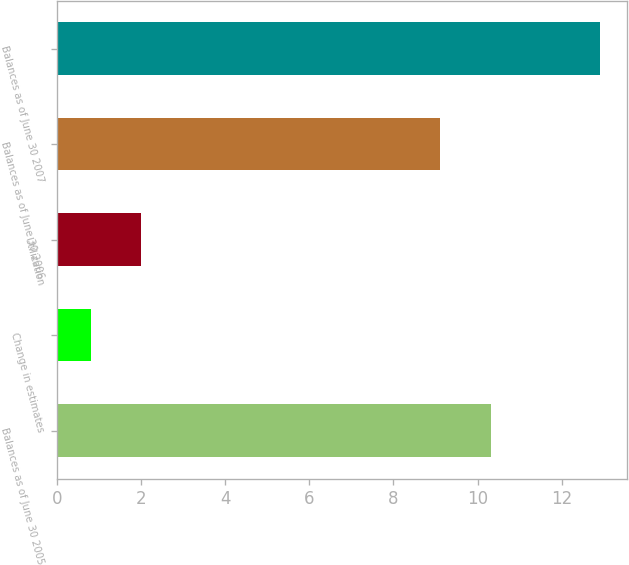Convert chart. <chart><loc_0><loc_0><loc_500><loc_500><bar_chart><fcel>Balances as of June 30 2005<fcel>Change in estimates<fcel>Utilization<fcel>Balances as of June 30 2006<fcel>Balances as of June 30 2007<nl><fcel>10.31<fcel>0.8<fcel>2.01<fcel>9.1<fcel>12.9<nl></chart> 